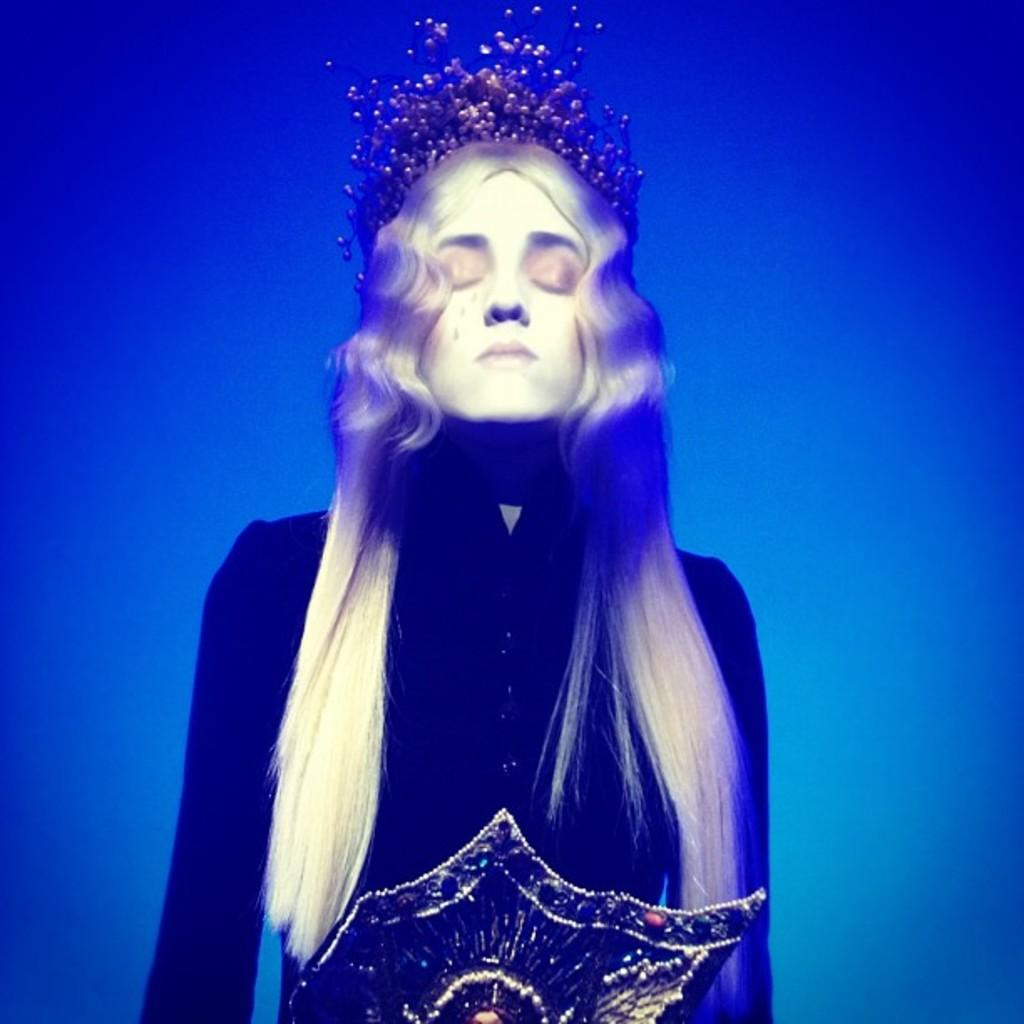Who or what is the main subject in the image? There is a person in the image. Can you describe the person's surroundings? The person is inside the water. What color is the water in the image? The water is in blue color. What is the person wearing? The person is wearing a dress. How many shoes are visible in the image? There are no shoes visible in the image, as the person is inside the water and not wearing any shoes. 